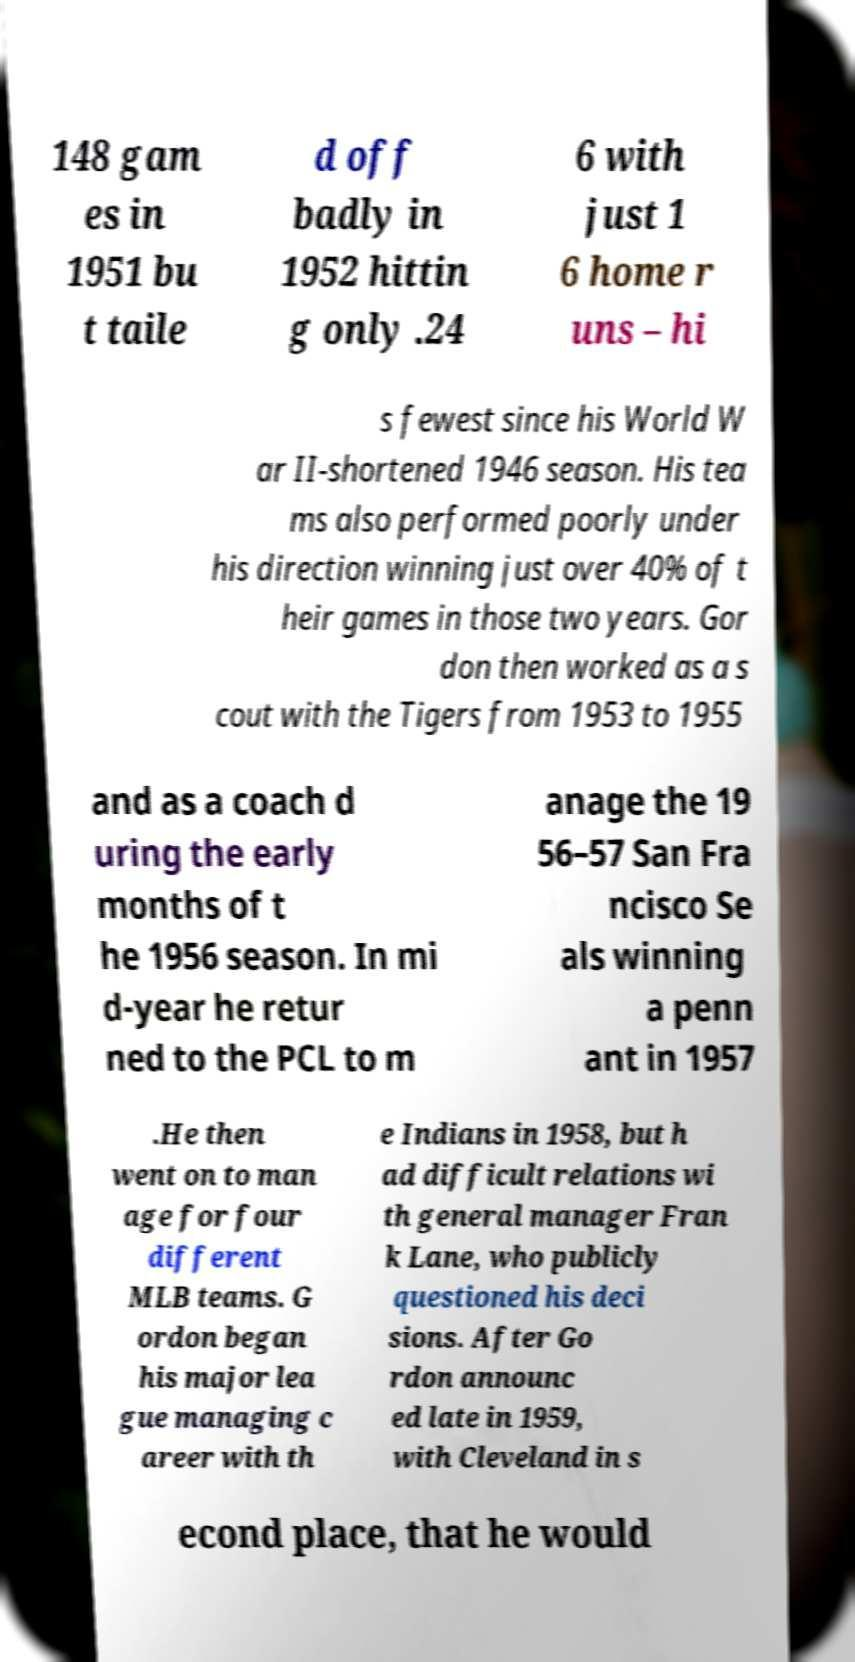Could you assist in decoding the text presented in this image and type it out clearly? 148 gam es in 1951 bu t taile d off badly in 1952 hittin g only .24 6 with just 1 6 home r uns – hi s fewest since his World W ar II-shortened 1946 season. His tea ms also performed poorly under his direction winning just over 40% of t heir games in those two years. Gor don then worked as a s cout with the Tigers from 1953 to 1955 and as a coach d uring the early months of t he 1956 season. In mi d-year he retur ned to the PCL to m anage the 19 56–57 San Fra ncisco Se als winning a penn ant in 1957 .He then went on to man age for four different MLB teams. G ordon began his major lea gue managing c areer with th e Indians in 1958, but h ad difficult relations wi th general manager Fran k Lane, who publicly questioned his deci sions. After Go rdon announc ed late in 1959, with Cleveland in s econd place, that he would 